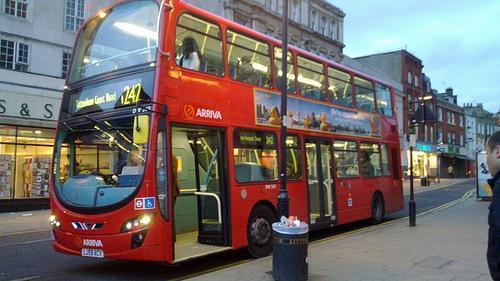How many levels does the bus have?
Give a very brief answer. 2. How many doors are open on the bus?
Give a very brief answer. 2. 